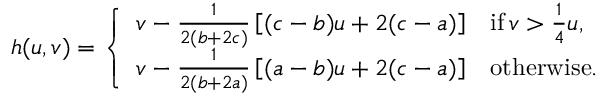<formula> <loc_0><loc_0><loc_500><loc_500>h ( u , v ) = \left \{ \begin{array} { l l } { v - \frac { 1 } { 2 ( b + 2 c ) } \left [ ( c - b ) u + 2 ( c - a ) \right ] } & { i f \, v > \frac { 1 } { 4 } u , } \\ { v - \frac { 1 } { 2 ( b + 2 a ) } \left [ ( a - b ) u + 2 ( c - a ) \right ] } & { o t h e r w i s e . } \end{array}</formula> 